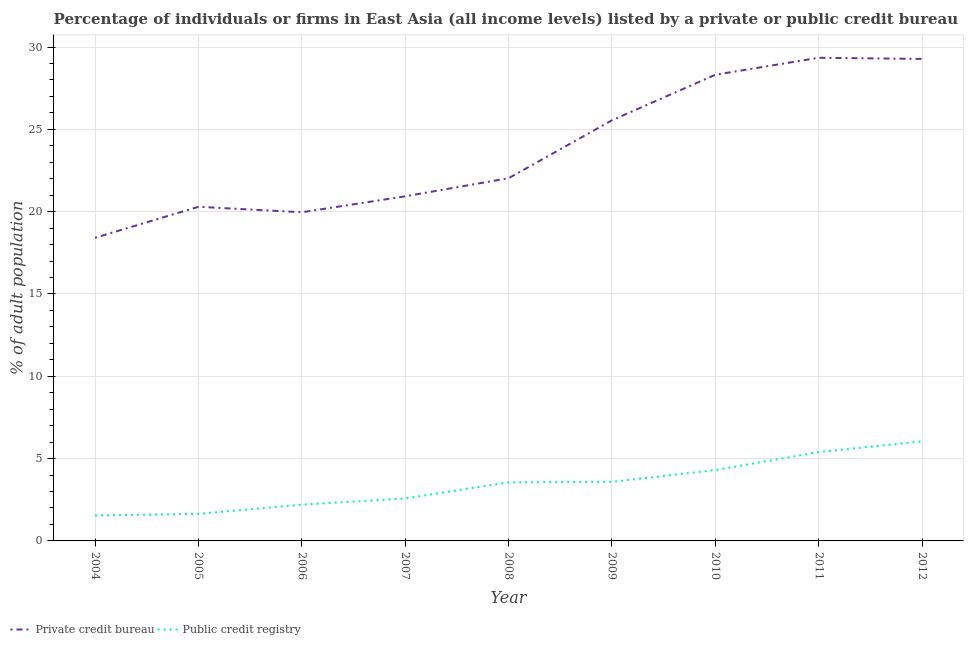Does the line corresponding to percentage of firms listed by public credit bureau intersect with the line corresponding to percentage of firms listed by private credit bureau?
Keep it short and to the point. No. What is the percentage of firms listed by public credit bureau in 2006?
Keep it short and to the point. 2.2. Across all years, what is the maximum percentage of firms listed by private credit bureau?
Your response must be concise. 29.35. Across all years, what is the minimum percentage of firms listed by public credit bureau?
Provide a succinct answer. 1.54. In which year was the percentage of firms listed by private credit bureau maximum?
Your response must be concise. 2011. What is the total percentage of firms listed by public credit bureau in the graph?
Keep it short and to the point. 30.87. What is the difference between the percentage of firms listed by public credit bureau in 2005 and that in 2012?
Offer a terse response. -4.4. What is the difference between the percentage of firms listed by public credit bureau in 2006 and the percentage of firms listed by private credit bureau in 2012?
Your answer should be compact. -27.07. What is the average percentage of firms listed by public credit bureau per year?
Your response must be concise. 3.43. In the year 2008, what is the difference between the percentage of firms listed by public credit bureau and percentage of firms listed by private credit bureau?
Your answer should be very brief. -18.47. In how many years, is the percentage of firms listed by public credit bureau greater than 1 %?
Your response must be concise. 9. What is the ratio of the percentage of firms listed by private credit bureau in 2009 to that in 2010?
Give a very brief answer. 0.9. What is the difference between the highest and the second highest percentage of firms listed by private credit bureau?
Provide a short and direct response. 0.07. What is the difference between the highest and the lowest percentage of firms listed by private credit bureau?
Give a very brief answer. 10.94. How many years are there in the graph?
Offer a terse response. 9. Does the graph contain any zero values?
Offer a terse response. No. Does the graph contain grids?
Offer a very short reply. Yes. Where does the legend appear in the graph?
Your response must be concise. Bottom left. How are the legend labels stacked?
Your answer should be compact. Horizontal. What is the title of the graph?
Your answer should be very brief. Percentage of individuals or firms in East Asia (all income levels) listed by a private or public credit bureau. What is the label or title of the Y-axis?
Provide a short and direct response. % of adult population. What is the % of adult population in Private credit bureau in 2004?
Provide a succinct answer. 18.41. What is the % of adult population in Public credit registry in 2004?
Your answer should be very brief. 1.54. What is the % of adult population of Private credit bureau in 2005?
Your answer should be compact. 20.3. What is the % of adult population of Public credit registry in 2005?
Keep it short and to the point. 1.65. What is the % of adult population in Private credit bureau in 2006?
Make the answer very short. 19.96. What is the % of adult population in Public credit registry in 2006?
Give a very brief answer. 2.2. What is the % of adult population in Private credit bureau in 2007?
Offer a terse response. 20.93. What is the % of adult population in Public credit registry in 2007?
Keep it short and to the point. 2.58. What is the % of adult population of Private credit bureau in 2008?
Your response must be concise. 22.03. What is the % of adult population in Public credit registry in 2008?
Give a very brief answer. 3.56. What is the % of adult population in Private credit bureau in 2009?
Keep it short and to the point. 25.55. What is the % of adult population of Public credit registry in 2009?
Provide a short and direct response. 3.59. What is the % of adult population in Private credit bureau in 2010?
Your response must be concise. 28.32. What is the % of adult population of Public credit registry in 2010?
Give a very brief answer. 4.3. What is the % of adult population in Private credit bureau in 2011?
Your answer should be compact. 29.35. What is the % of adult population in Public credit registry in 2011?
Your answer should be compact. 5.4. What is the % of adult population in Private credit bureau in 2012?
Offer a very short reply. 29.28. What is the % of adult population of Public credit registry in 2012?
Your answer should be very brief. 6.05. Across all years, what is the maximum % of adult population of Private credit bureau?
Your answer should be compact. 29.35. Across all years, what is the maximum % of adult population in Public credit registry?
Keep it short and to the point. 6.05. Across all years, what is the minimum % of adult population of Private credit bureau?
Provide a short and direct response. 18.41. Across all years, what is the minimum % of adult population in Public credit registry?
Keep it short and to the point. 1.54. What is the total % of adult population of Private credit bureau in the graph?
Offer a very short reply. 214.13. What is the total % of adult population in Public credit registry in the graph?
Give a very brief answer. 30.87. What is the difference between the % of adult population of Private credit bureau in 2004 and that in 2005?
Your response must be concise. -1.88. What is the difference between the % of adult population in Public credit registry in 2004 and that in 2005?
Keep it short and to the point. -0.1. What is the difference between the % of adult population in Private credit bureau in 2004 and that in 2006?
Your response must be concise. -1.55. What is the difference between the % of adult population of Public credit registry in 2004 and that in 2006?
Your response must be concise. -0.66. What is the difference between the % of adult population of Private credit bureau in 2004 and that in 2007?
Provide a short and direct response. -2.52. What is the difference between the % of adult population of Public credit registry in 2004 and that in 2007?
Make the answer very short. -1.04. What is the difference between the % of adult population of Private credit bureau in 2004 and that in 2008?
Make the answer very short. -3.62. What is the difference between the % of adult population of Public credit registry in 2004 and that in 2008?
Keep it short and to the point. -2.02. What is the difference between the % of adult population of Private credit bureau in 2004 and that in 2009?
Make the answer very short. -7.14. What is the difference between the % of adult population of Public credit registry in 2004 and that in 2009?
Provide a short and direct response. -2.05. What is the difference between the % of adult population in Private credit bureau in 2004 and that in 2010?
Your answer should be very brief. -9.9. What is the difference between the % of adult population of Public credit registry in 2004 and that in 2010?
Provide a short and direct response. -2.76. What is the difference between the % of adult population in Private credit bureau in 2004 and that in 2011?
Offer a very short reply. -10.94. What is the difference between the % of adult population in Public credit registry in 2004 and that in 2011?
Provide a succinct answer. -3.85. What is the difference between the % of adult population in Private credit bureau in 2004 and that in 2012?
Give a very brief answer. -10.86. What is the difference between the % of adult population of Public credit registry in 2004 and that in 2012?
Your answer should be compact. -4.51. What is the difference between the % of adult population in Private credit bureau in 2005 and that in 2006?
Make the answer very short. 0.33. What is the difference between the % of adult population in Public credit registry in 2005 and that in 2006?
Ensure brevity in your answer.  -0.56. What is the difference between the % of adult population of Private credit bureau in 2005 and that in 2007?
Your answer should be very brief. -0.64. What is the difference between the % of adult population of Public credit registry in 2005 and that in 2007?
Provide a succinct answer. -0.93. What is the difference between the % of adult population in Private credit bureau in 2005 and that in 2008?
Your answer should be very brief. -1.74. What is the difference between the % of adult population of Public credit registry in 2005 and that in 2008?
Provide a succinct answer. -1.91. What is the difference between the % of adult population in Private credit bureau in 2005 and that in 2009?
Provide a short and direct response. -5.26. What is the difference between the % of adult population in Public credit registry in 2005 and that in 2009?
Give a very brief answer. -1.94. What is the difference between the % of adult population of Private credit bureau in 2005 and that in 2010?
Your answer should be compact. -8.02. What is the difference between the % of adult population of Public credit registry in 2005 and that in 2010?
Provide a short and direct response. -2.66. What is the difference between the % of adult population of Private credit bureau in 2005 and that in 2011?
Make the answer very short. -9.05. What is the difference between the % of adult population in Public credit registry in 2005 and that in 2011?
Offer a very short reply. -3.75. What is the difference between the % of adult population in Private credit bureau in 2005 and that in 2012?
Ensure brevity in your answer.  -8.98. What is the difference between the % of adult population in Public credit registry in 2005 and that in 2012?
Provide a succinct answer. -4.4. What is the difference between the % of adult population of Private credit bureau in 2006 and that in 2007?
Keep it short and to the point. -0.97. What is the difference between the % of adult population in Public credit registry in 2006 and that in 2007?
Ensure brevity in your answer.  -0.38. What is the difference between the % of adult population in Private credit bureau in 2006 and that in 2008?
Make the answer very short. -2.07. What is the difference between the % of adult population of Public credit registry in 2006 and that in 2008?
Give a very brief answer. -1.36. What is the difference between the % of adult population of Private credit bureau in 2006 and that in 2009?
Provide a short and direct response. -5.59. What is the difference between the % of adult population of Public credit registry in 2006 and that in 2009?
Your answer should be very brief. -1.38. What is the difference between the % of adult population of Private credit bureau in 2006 and that in 2010?
Offer a terse response. -8.35. What is the difference between the % of adult population of Public credit registry in 2006 and that in 2010?
Provide a succinct answer. -2.1. What is the difference between the % of adult population in Private credit bureau in 2006 and that in 2011?
Ensure brevity in your answer.  -9.38. What is the difference between the % of adult population of Public credit registry in 2006 and that in 2011?
Offer a terse response. -3.19. What is the difference between the % of adult population of Private credit bureau in 2006 and that in 2012?
Provide a short and direct response. -9.31. What is the difference between the % of adult population of Public credit registry in 2006 and that in 2012?
Ensure brevity in your answer.  -3.85. What is the difference between the % of adult population of Public credit registry in 2007 and that in 2008?
Offer a very short reply. -0.98. What is the difference between the % of adult population of Private credit bureau in 2007 and that in 2009?
Keep it short and to the point. -4.62. What is the difference between the % of adult population in Public credit registry in 2007 and that in 2009?
Keep it short and to the point. -1.01. What is the difference between the % of adult population of Private credit bureau in 2007 and that in 2010?
Offer a very short reply. -7.38. What is the difference between the % of adult population in Public credit registry in 2007 and that in 2010?
Provide a succinct answer. -1.72. What is the difference between the % of adult population of Private credit bureau in 2007 and that in 2011?
Offer a terse response. -8.42. What is the difference between the % of adult population in Public credit registry in 2007 and that in 2011?
Your answer should be compact. -2.82. What is the difference between the % of adult population in Private credit bureau in 2007 and that in 2012?
Ensure brevity in your answer.  -8.34. What is the difference between the % of adult population of Public credit registry in 2007 and that in 2012?
Offer a very short reply. -3.47. What is the difference between the % of adult population of Private credit bureau in 2008 and that in 2009?
Provide a succinct answer. -3.52. What is the difference between the % of adult population in Public credit registry in 2008 and that in 2009?
Your answer should be very brief. -0.03. What is the difference between the % of adult population of Private credit bureau in 2008 and that in 2010?
Give a very brief answer. -6.28. What is the difference between the % of adult population of Public credit registry in 2008 and that in 2010?
Offer a terse response. -0.74. What is the difference between the % of adult population of Private credit bureau in 2008 and that in 2011?
Your answer should be compact. -7.32. What is the difference between the % of adult population of Public credit registry in 2008 and that in 2011?
Offer a terse response. -1.84. What is the difference between the % of adult population of Private credit bureau in 2008 and that in 2012?
Provide a succinct answer. -7.24. What is the difference between the % of adult population of Public credit registry in 2008 and that in 2012?
Offer a very short reply. -2.49. What is the difference between the % of adult population in Private credit bureau in 2009 and that in 2010?
Offer a terse response. -2.76. What is the difference between the % of adult population of Public credit registry in 2009 and that in 2010?
Provide a short and direct response. -0.72. What is the difference between the % of adult population in Private credit bureau in 2009 and that in 2011?
Make the answer very short. -3.8. What is the difference between the % of adult population in Public credit registry in 2009 and that in 2011?
Your answer should be compact. -1.81. What is the difference between the % of adult population of Private credit bureau in 2009 and that in 2012?
Your answer should be compact. -3.72. What is the difference between the % of adult population in Public credit registry in 2009 and that in 2012?
Give a very brief answer. -2.46. What is the difference between the % of adult population in Private credit bureau in 2010 and that in 2011?
Your answer should be very brief. -1.03. What is the difference between the % of adult population of Public credit registry in 2010 and that in 2011?
Keep it short and to the point. -1.09. What is the difference between the % of adult population in Private credit bureau in 2010 and that in 2012?
Your answer should be very brief. -0.96. What is the difference between the % of adult population of Public credit registry in 2010 and that in 2012?
Offer a terse response. -1.75. What is the difference between the % of adult population of Private credit bureau in 2011 and that in 2012?
Provide a succinct answer. 0.07. What is the difference between the % of adult population in Public credit registry in 2011 and that in 2012?
Make the answer very short. -0.65. What is the difference between the % of adult population in Private credit bureau in 2004 and the % of adult population in Public credit registry in 2005?
Provide a succinct answer. 16.77. What is the difference between the % of adult population in Private credit bureau in 2004 and the % of adult population in Public credit registry in 2006?
Give a very brief answer. 16.21. What is the difference between the % of adult population in Private credit bureau in 2004 and the % of adult population in Public credit registry in 2007?
Offer a very short reply. 15.83. What is the difference between the % of adult population of Private credit bureau in 2004 and the % of adult population of Public credit registry in 2008?
Give a very brief answer. 14.85. What is the difference between the % of adult population in Private credit bureau in 2004 and the % of adult population in Public credit registry in 2009?
Your answer should be compact. 14.82. What is the difference between the % of adult population in Private credit bureau in 2004 and the % of adult population in Public credit registry in 2010?
Offer a terse response. 14.11. What is the difference between the % of adult population of Private credit bureau in 2004 and the % of adult population of Public credit registry in 2011?
Offer a very short reply. 13.02. What is the difference between the % of adult population of Private credit bureau in 2004 and the % of adult population of Public credit registry in 2012?
Your answer should be very brief. 12.36. What is the difference between the % of adult population in Private credit bureau in 2005 and the % of adult population in Public credit registry in 2006?
Offer a very short reply. 18.09. What is the difference between the % of adult population in Private credit bureau in 2005 and the % of adult population in Public credit registry in 2007?
Offer a terse response. 17.72. What is the difference between the % of adult population in Private credit bureau in 2005 and the % of adult population in Public credit registry in 2008?
Your answer should be very brief. 16.74. What is the difference between the % of adult population of Private credit bureau in 2005 and the % of adult population of Public credit registry in 2009?
Your response must be concise. 16.71. What is the difference between the % of adult population in Private credit bureau in 2005 and the % of adult population in Public credit registry in 2010?
Give a very brief answer. 15.99. What is the difference between the % of adult population of Private credit bureau in 2005 and the % of adult population of Public credit registry in 2011?
Make the answer very short. 14.9. What is the difference between the % of adult population of Private credit bureau in 2005 and the % of adult population of Public credit registry in 2012?
Provide a short and direct response. 14.25. What is the difference between the % of adult population of Private credit bureau in 2006 and the % of adult population of Public credit registry in 2007?
Offer a very short reply. 17.38. What is the difference between the % of adult population in Private credit bureau in 2006 and the % of adult population in Public credit registry in 2008?
Your response must be concise. 16.4. What is the difference between the % of adult population of Private credit bureau in 2006 and the % of adult population of Public credit registry in 2009?
Ensure brevity in your answer.  16.38. What is the difference between the % of adult population of Private credit bureau in 2006 and the % of adult population of Public credit registry in 2010?
Your answer should be very brief. 15.66. What is the difference between the % of adult population in Private credit bureau in 2006 and the % of adult population in Public credit registry in 2011?
Offer a very short reply. 14.57. What is the difference between the % of adult population in Private credit bureau in 2006 and the % of adult population in Public credit registry in 2012?
Your answer should be very brief. 13.91. What is the difference between the % of adult population of Private credit bureau in 2007 and the % of adult population of Public credit registry in 2008?
Your answer should be compact. 17.37. What is the difference between the % of adult population of Private credit bureau in 2007 and the % of adult population of Public credit registry in 2009?
Keep it short and to the point. 17.34. What is the difference between the % of adult population in Private credit bureau in 2007 and the % of adult population in Public credit registry in 2010?
Keep it short and to the point. 16.63. What is the difference between the % of adult population in Private credit bureau in 2007 and the % of adult population in Public credit registry in 2011?
Make the answer very short. 15.54. What is the difference between the % of adult population of Private credit bureau in 2007 and the % of adult population of Public credit registry in 2012?
Ensure brevity in your answer.  14.88. What is the difference between the % of adult population of Private credit bureau in 2008 and the % of adult population of Public credit registry in 2009?
Your answer should be very brief. 18.44. What is the difference between the % of adult population in Private credit bureau in 2008 and the % of adult population in Public credit registry in 2010?
Keep it short and to the point. 17.73. What is the difference between the % of adult population in Private credit bureau in 2008 and the % of adult population in Public credit registry in 2011?
Provide a succinct answer. 16.64. What is the difference between the % of adult population in Private credit bureau in 2008 and the % of adult population in Public credit registry in 2012?
Offer a terse response. 15.98. What is the difference between the % of adult population in Private credit bureau in 2009 and the % of adult population in Public credit registry in 2010?
Your answer should be compact. 21.25. What is the difference between the % of adult population of Private credit bureau in 2009 and the % of adult population of Public credit registry in 2011?
Give a very brief answer. 20.16. What is the difference between the % of adult population of Private credit bureau in 2009 and the % of adult population of Public credit registry in 2012?
Offer a very short reply. 19.5. What is the difference between the % of adult population in Private credit bureau in 2010 and the % of adult population in Public credit registry in 2011?
Your response must be concise. 22.92. What is the difference between the % of adult population of Private credit bureau in 2010 and the % of adult population of Public credit registry in 2012?
Your response must be concise. 22.27. What is the difference between the % of adult population in Private credit bureau in 2011 and the % of adult population in Public credit registry in 2012?
Keep it short and to the point. 23.3. What is the average % of adult population in Private credit bureau per year?
Keep it short and to the point. 23.79. What is the average % of adult population of Public credit registry per year?
Provide a short and direct response. 3.43. In the year 2004, what is the difference between the % of adult population of Private credit bureau and % of adult population of Public credit registry?
Offer a terse response. 16.87. In the year 2005, what is the difference between the % of adult population in Private credit bureau and % of adult population in Public credit registry?
Your response must be concise. 18.65. In the year 2006, what is the difference between the % of adult population of Private credit bureau and % of adult population of Public credit registry?
Your answer should be very brief. 17.76. In the year 2007, what is the difference between the % of adult population of Private credit bureau and % of adult population of Public credit registry?
Make the answer very short. 18.35. In the year 2008, what is the difference between the % of adult population in Private credit bureau and % of adult population in Public credit registry?
Your answer should be compact. 18.47. In the year 2009, what is the difference between the % of adult population of Private credit bureau and % of adult population of Public credit registry?
Keep it short and to the point. 21.96. In the year 2010, what is the difference between the % of adult population in Private credit bureau and % of adult population in Public credit registry?
Provide a succinct answer. 24.01. In the year 2011, what is the difference between the % of adult population of Private credit bureau and % of adult population of Public credit registry?
Keep it short and to the point. 23.95. In the year 2012, what is the difference between the % of adult population in Private credit bureau and % of adult population in Public credit registry?
Your response must be concise. 23.23. What is the ratio of the % of adult population in Private credit bureau in 2004 to that in 2005?
Provide a succinct answer. 0.91. What is the ratio of the % of adult population in Public credit registry in 2004 to that in 2005?
Provide a succinct answer. 0.94. What is the ratio of the % of adult population in Private credit bureau in 2004 to that in 2006?
Keep it short and to the point. 0.92. What is the ratio of the % of adult population of Public credit registry in 2004 to that in 2006?
Give a very brief answer. 0.7. What is the ratio of the % of adult population in Private credit bureau in 2004 to that in 2007?
Your answer should be compact. 0.88. What is the ratio of the % of adult population of Public credit registry in 2004 to that in 2007?
Your answer should be very brief. 0.6. What is the ratio of the % of adult population in Private credit bureau in 2004 to that in 2008?
Ensure brevity in your answer.  0.84. What is the ratio of the % of adult population of Public credit registry in 2004 to that in 2008?
Make the answer very short. 0.43. What is the ratio of the % of adult population of Private credit bureau in 2004 to that in 2009?
Give a very brief answer. 0.72. What is the ratio of the % of adult population of Public credit registry in 2004 to that in 2009?
Keep it short and to the point. 0.43. What is the ratio of the % of adult population of Private credit bureau in 2004 to that in 2010?
Keep it short and to the point. 0.65. What is the ratio of the % of adult population of Public credit registry in 2004 to that in 2010?
Make the answer very short. 0.36. What is the ratio of the % of adult population in Private credit bureau in 2004 to that in 2011?
Keep it short and to the point. 0.63. What is the ratio of the % of adult population of Public credit registry in 2004 to that in 2011?
Provide a short and direct response. 0.29. What is the ratio of the % of adult population of Private credit bureau in 2004 to that in 2012?
Make the answer very short. 0.63. What is the ratio of the % of adult population of Public credit registry in 2004 to that in 2012?
Your answer should be very brief. 0.25. What is the ratio of the % of adult population of Private credit bureau in 2005 to that in 2006?
Keep it short and to the point. 1.02. What is the ratio of the % of adult population in Public credit registry in 2005 to that in 2006?
Offer a terse response. 0.75. What is the ratio of the % of adult population of Private credit bureau in 2005 to that in 2007?
Ensure brevity in your answer.  0.97. What is the ratio of the % of adult population of Public credit registry in 2005 to that in 2007?
Provide a short and direct response. 0.64. What is the ratio of the % of adult population in Private credit bureau in 2005 to that in 2008?
Give a very brief answer. 0.92. What is the ratio of the % of adult population in Public credit registry in 2005 to that in 2008?
Your response must be concise. 0.46. What is the ratio of the % of adult population in Private credit bureau in 2005 to that in 2009?
Keep it short and to the point. 0.79. What is the ratio of the % of adult population in Public credit registry in 2005 to that in 2009?
Give a very brief answer. 0.46. What is the ratio of the % of adult population in Private credit bureau in 2005 to that in 2010?
Your answer should be compact. 0.72. What is the ratio of the % of adult population in Public credit registry in 2005 to that in 2010?
Your answer should be compact. 0.38. What is the ratio of the % of adult population in Private credit bureau in 2005 to that in 2011?
Your answer should be very brief. 0.69. What is the ratio of the % of adult population in Public credit registry in 2005 to that in 2011?
Offer a very short reply. 0.3. What is the ratio of the % of adult population of Private credit bureau in 2005 to that in 2012?
Offer a terse response. 0.69. What is the ratio of the % of adult population in Public credit registry in 2005 to that in 2012?
Provide a short and direct response. 0.27. What is the ratio of the % of adult population of Private credit bureau in 2006 to that in 2007?
Your answer should be very brief. 0.95. What is the ratio of the % of adult population in Public credit registry in 2006 to that in 2007?
Make the answer very short. 0.85. What is the ratio of the % of adult population of Private credit bureau in 2006 to that in 2008?
Make the answer very short. 0.91. What is the ratio of the % of adult population in Public credit registry in 2006 to that in 2008?
Your answer should be very brief. 0.62. What is the ratio of the % of adult population of Private credit bureau in 2006 to that in 2009?
Your answer should be compact. 0.78. What is the ratio of the % of adult population of Public credit registry in 2006 to that in 2009?
Offer a terse response. 0.61. What is the ratio of the % of adult population in Private credit bureau in 2006 to that in 2010?
Your response must be concise. 0.7. What is the ratio of the % of adult population of Public credit registry in 2006 to that in 2010?
Offer a terse response. 0.51. What is the ratio of the % of adult population in Private credit bureau in 2006 to that in 2011?
Provide a succinct answer. 0.68. What is the ratio of the % of adult population of Public credit registry in 2006 to that in 2011?
Your response must be concise. 0.41. What is the ratio of the % of adult population in Private credit bureau in 2006 to that in 2012?
Offer a very short reply. 0.68. What is the ratio of the % of adult population of Public credit registry in 2006 to that in 2012?
Your response must be concise. 0.36. What is the ratio of the % of adult population in Private credit bureau in 2007 to that in 2008?
Your response must be concise. 0.95. What is the ratio of the % of adult population in Public credit registry in 2007 to that in 2008?
Your answer should be very brief. 0.72. What is the ratio of the % of adult population in Private credit bureau in 2007 to that in 2009?
Your answer should be compact. 0.82. What is the ratio of the % of adult population in Public credit registry in 2007 to that in 2009?
Your answer should be compact. 0.72. What is the ratio of the % of adult population of Private credit bureau in 2007 to that in 2010?
Offer a very short reply. 0.74. What is the ratio of the % of adult population of Public credit registry in 2007 to that in 2010?
Give a very brief answer. 0.6. What is the ratio of the % of adult population of Private credit bureau in 2007 to that in 2011?
Your answer should be very brief. 0.71. What is the ratio of the % of adult population of Public credit registry in 2007 to that in 2011?
Your answer should be compact. 0.48. What is the ratio of the % of adult population in Private credit bureau in 2007 to that in 2012?
Provide a short and direct response. 0.71. What is the ratio of the % of adult population of Public credit registry in 2007 to that in 2012?
Provide a succinct answer. 0.43. What is the ratio of the % of adult population of Private credit bureau in 2008 to that in 2009?
Your answer should be very brief. 0.86. What is the ratio of the % of adult population of Private credit bureau in 2008 to that in 2010?
Keep it short and to the point. 0.78. What is the ratio of the % of adult population in Public credit registry in 2008 to that in 2010?
Provide a succinct answer. 0.83. What is the ratio of the % of adult population in Private credit bureau in 2008 to that in 2011?
Your answer should be very brief. 0.75. What is the ratio of the % of adult population of Public credit registry in 2008 to that in 2011?
Offer a very short reply. 0.66. What is the ratio of the % of adult population in Private credit bureau in 2008 to that in 2012?
Ensure brevity in your answer.  0.75. What is the ratio of the % of adult population of Public credit registry in 2008 to that in 2012?
Offer a terse response. 0.59. What is the ratio of the % of adult population in Private credit bureau in 2009 to that in 2010?
Give a very brief answer. 0.9. What is the ratio of the % of adult population of Public credit registry in 2009 to that in 2010?
Offer a terse response. 0.83. What is the ratio of the % of adult population of Private credit bureau in 2009 to that in 2011?
Your answer should be compact. 0.87. What is the ratio of the % of adult population in Public credit registry in 2009 to that in 2011?
Provide a short and direct response. 0.66. What is the ratio of the % of adult population of Private credit bureau in 2009 to that in 2012?
Ensure brevity in your answer.  0.87. What is the ratio of the % of adult population of Public credit registry in 2009 to that in 2012?
Give a very brief answer. 0.59. What is the ratio of the % of adult population of Private credit bureau in 2010 to that in 2011?
Provide a short and direct response. 0.96. What is the ratio of the % of adult population in Public credit registry in 2010 to that in 2011?
Provide a short and direct response. 0.8. What is the ratio of the % of adult population in Private credit bureau in 2010 to that in 2012?
Make the answer very short. 0.97. What is the ratio of the % of adult population in Public credit registry in 2010 to that in 2012?
Keep it short and to the point. 0.71. What is the ratio of the % of adult population in Private credit bureau in 2011 to that in 2012?
Make the answer very short. 1. What is the ratio of the % of adult population in Public credit registry in 2011 to that in 2012?
Your response must be concise. 0.89. What is the difference between the highest and the second highest % of adult population of Private credit bureau?
Provide a short and direct response. 0.07. What is the difference between the highest and the second highest % of adult population in Public credit registry?
Give a very brief answer. 0.65. What is the difference between the highest and the lowest % of adult population in Private credit bureau?
Offer a very short reply. 10.94. What is the difference between the highest and the lowest % of adult population of Public credit registry?
Give a very brief answer. 4.51. 